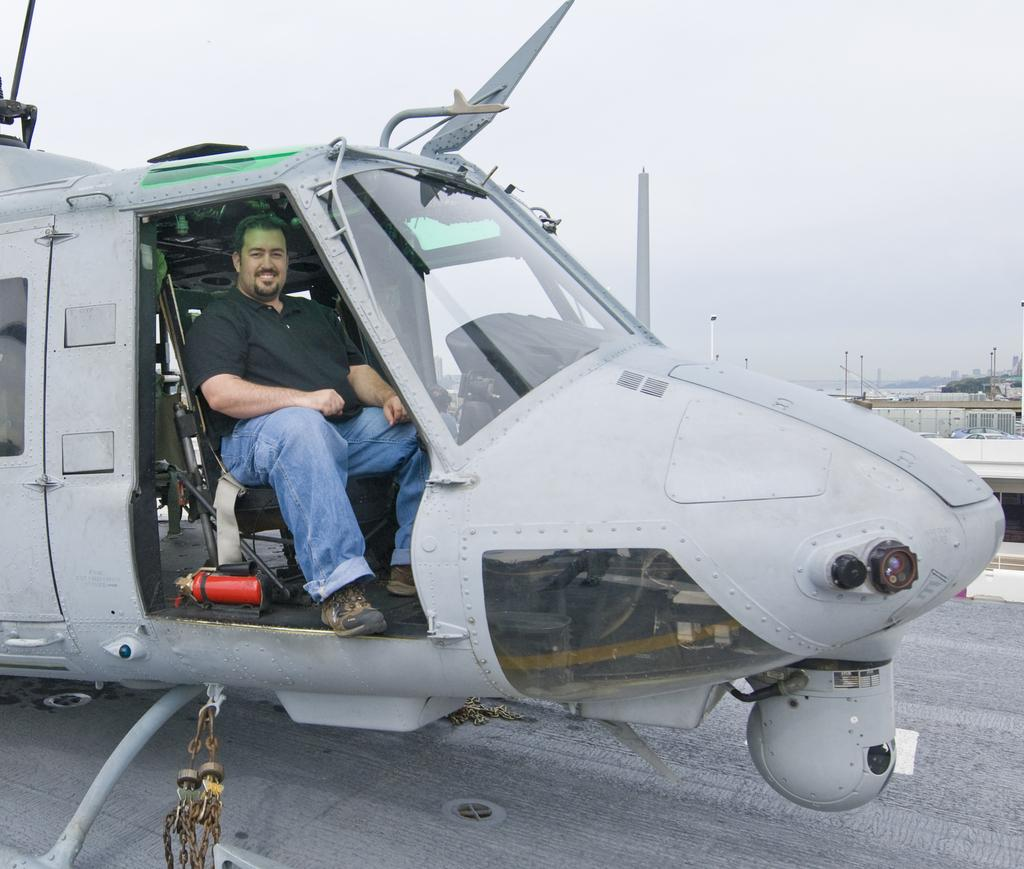What is: What is the main subject of the image? The main subject of the image is an airplane. Where is the airplane located in the image? The airplane is on the ground. Can you describe the person inside the airplane? There is a man sitting inside the airplane, and he is smiling. What can be seen in the background of the image? There are poles and the sky visible in the background of the image. How many kittens are playing on the swing in the image? There are no kittens or swings present in the image. What direction does the airplane turn in the image? The airplane is not turning in the image; it is stationary on the ground. 